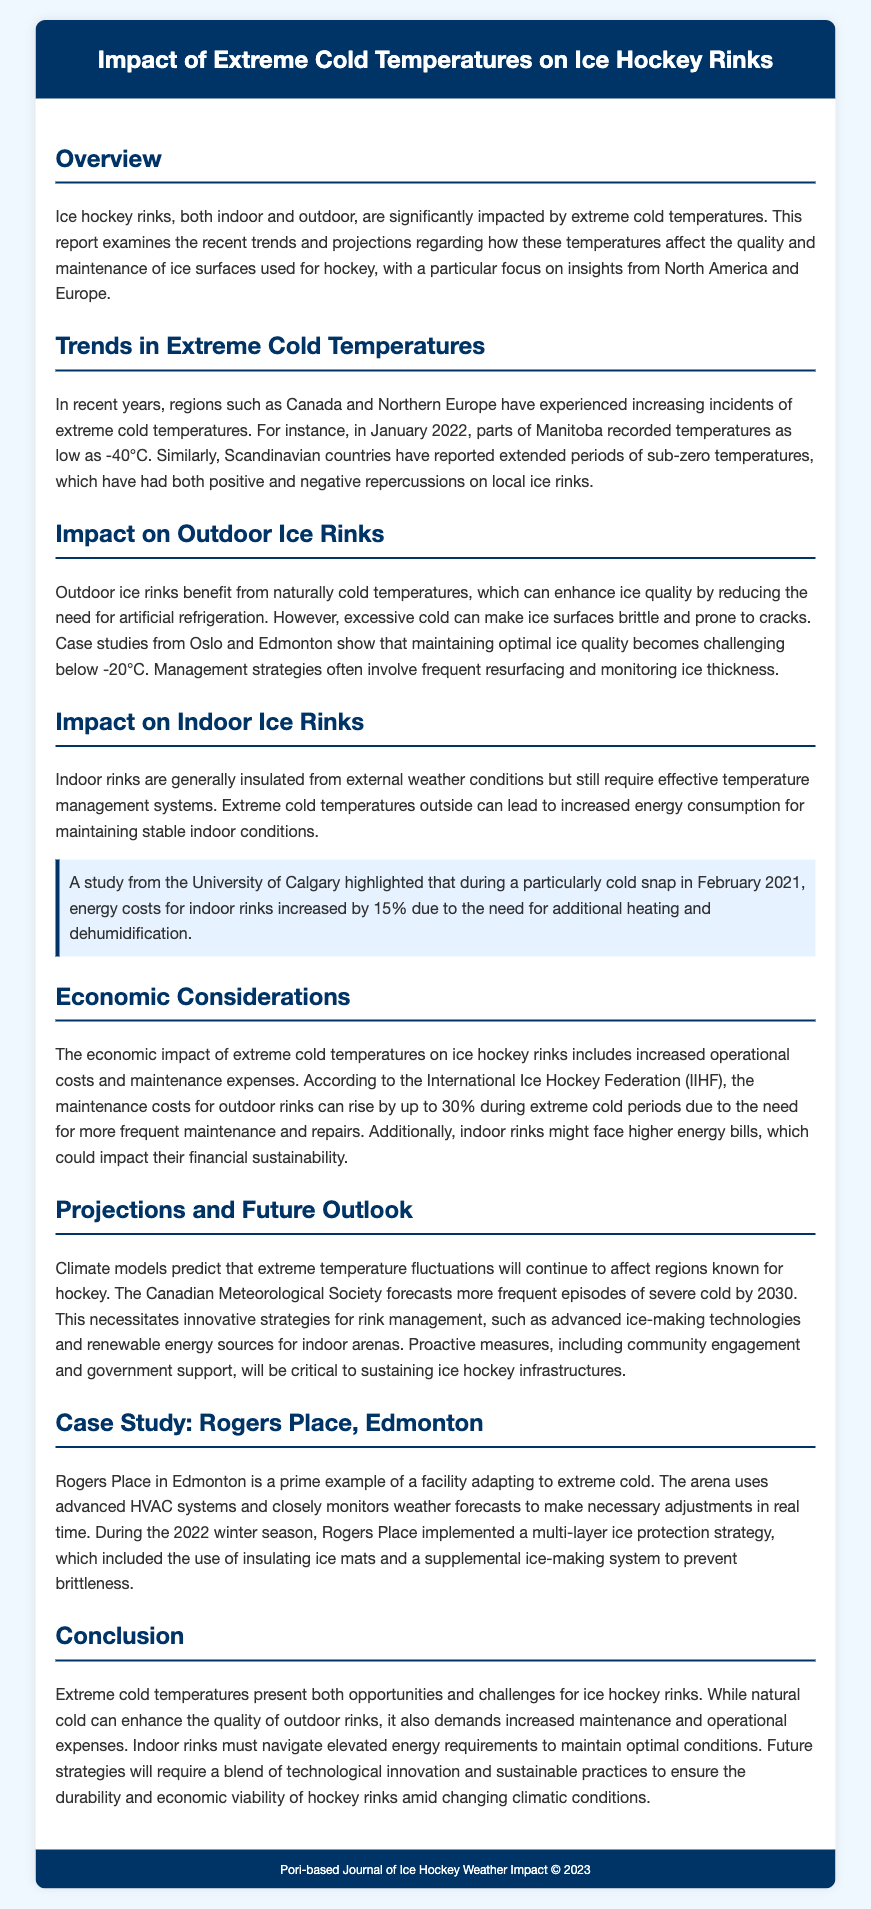What is the title of the report? The title of the report is prominently displayed at the top of the document.
Answer: Impact of Extreme Cold Temperatures on Ice Hockey Rinks Which region experienced temperatures as low as -40°C? The document mentions specific regions that have faced extreme temperatures, including Manitoba.
Answer: Manitoba What percentage did energy costs increase by during the cold snap in February 2021? A specific study highlighted the energy cost increase in response to extreme cold temperatures.
Answer: 15% What is the potential maintenance cost rise for outdoor rinks during extreme cold periods? The document provides a specific estimate from the International Ice Hockey Federation.
Answer: 30% What protective strategy did Rogers Place implement during the 2022 winter season? The document describes a particular strategy that was adopted to deal with extreme cold conditions.
Answer: Multi-layer ice protection strategy Which countries have reported extended periods of sub-zero temperatures? The document specifically references regions that have been affected by extended cold periods.
Answer: Scandinavian countries 